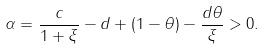Convert formula to latex. <formula><loc_0><loc_0><loc_500><loc_500>\alpha = \frac { c } { 1 + \xi } - d + ( 1 - \theta ) - \frac { d \theta } { \xi } > 0 .</formula> 